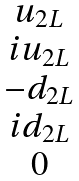Convert formula to latex. <formula><loc_0><loc_0><loc_500><loc_500>\begin{matrix} u _ { 2 L } \\ i u _ { 2 L } \\ - d _ { 2 L } \\ i d _ { 2 L } \\ 0 \end{matrix}</formula> 